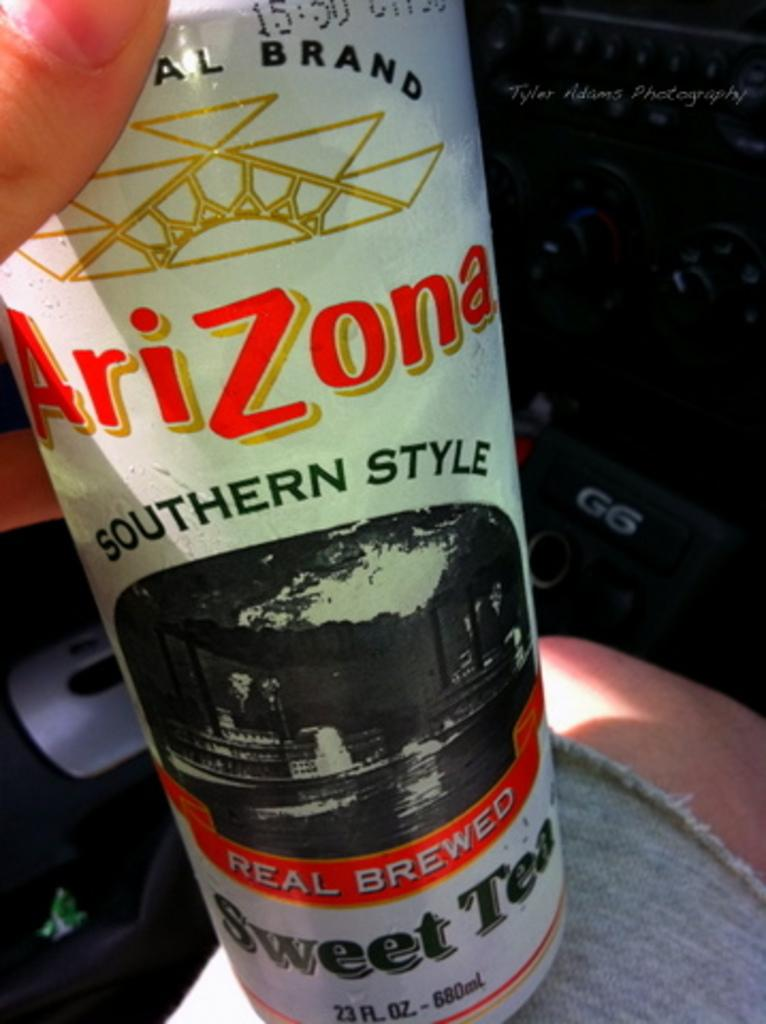<image>
Describe the image concisely. A person is holding a bottle of Arizona Southern Style Sweet Tea. 